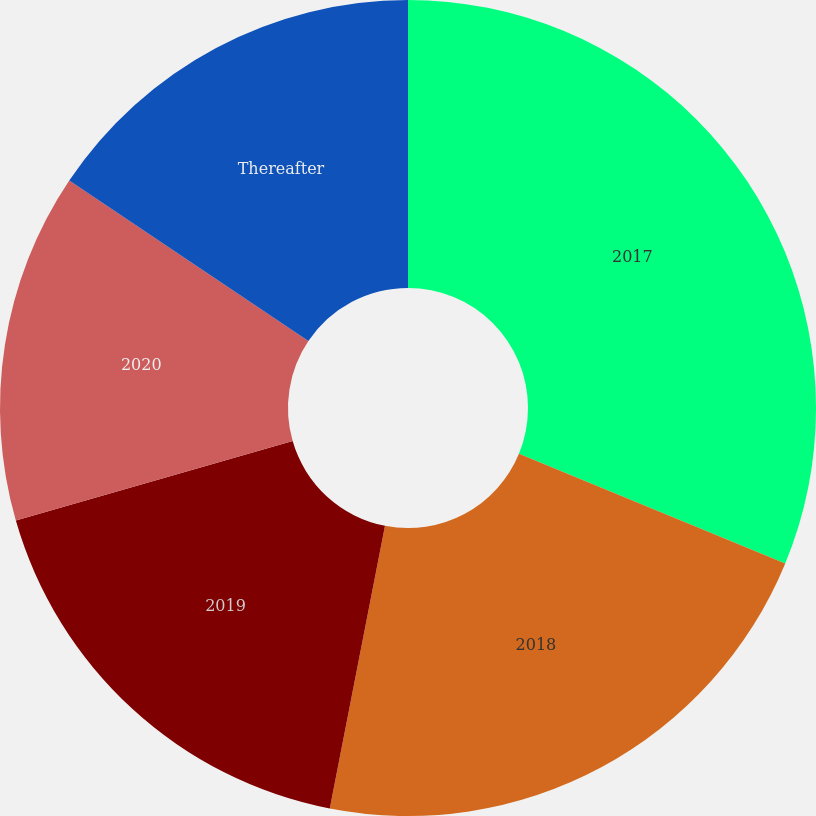Convert chart to OTSL. <chart><loc_0><loc_0><loc_500><loc_500><pie_chart><fcel>2017<fcel>2018<fcel>2019<fcel>2020<fcel>Thereafter<nl><fcel>31.22%<fcel>21.85%<fcel>17.48%<fcel>13.86%<fcel>15.59%<nl></chart> 